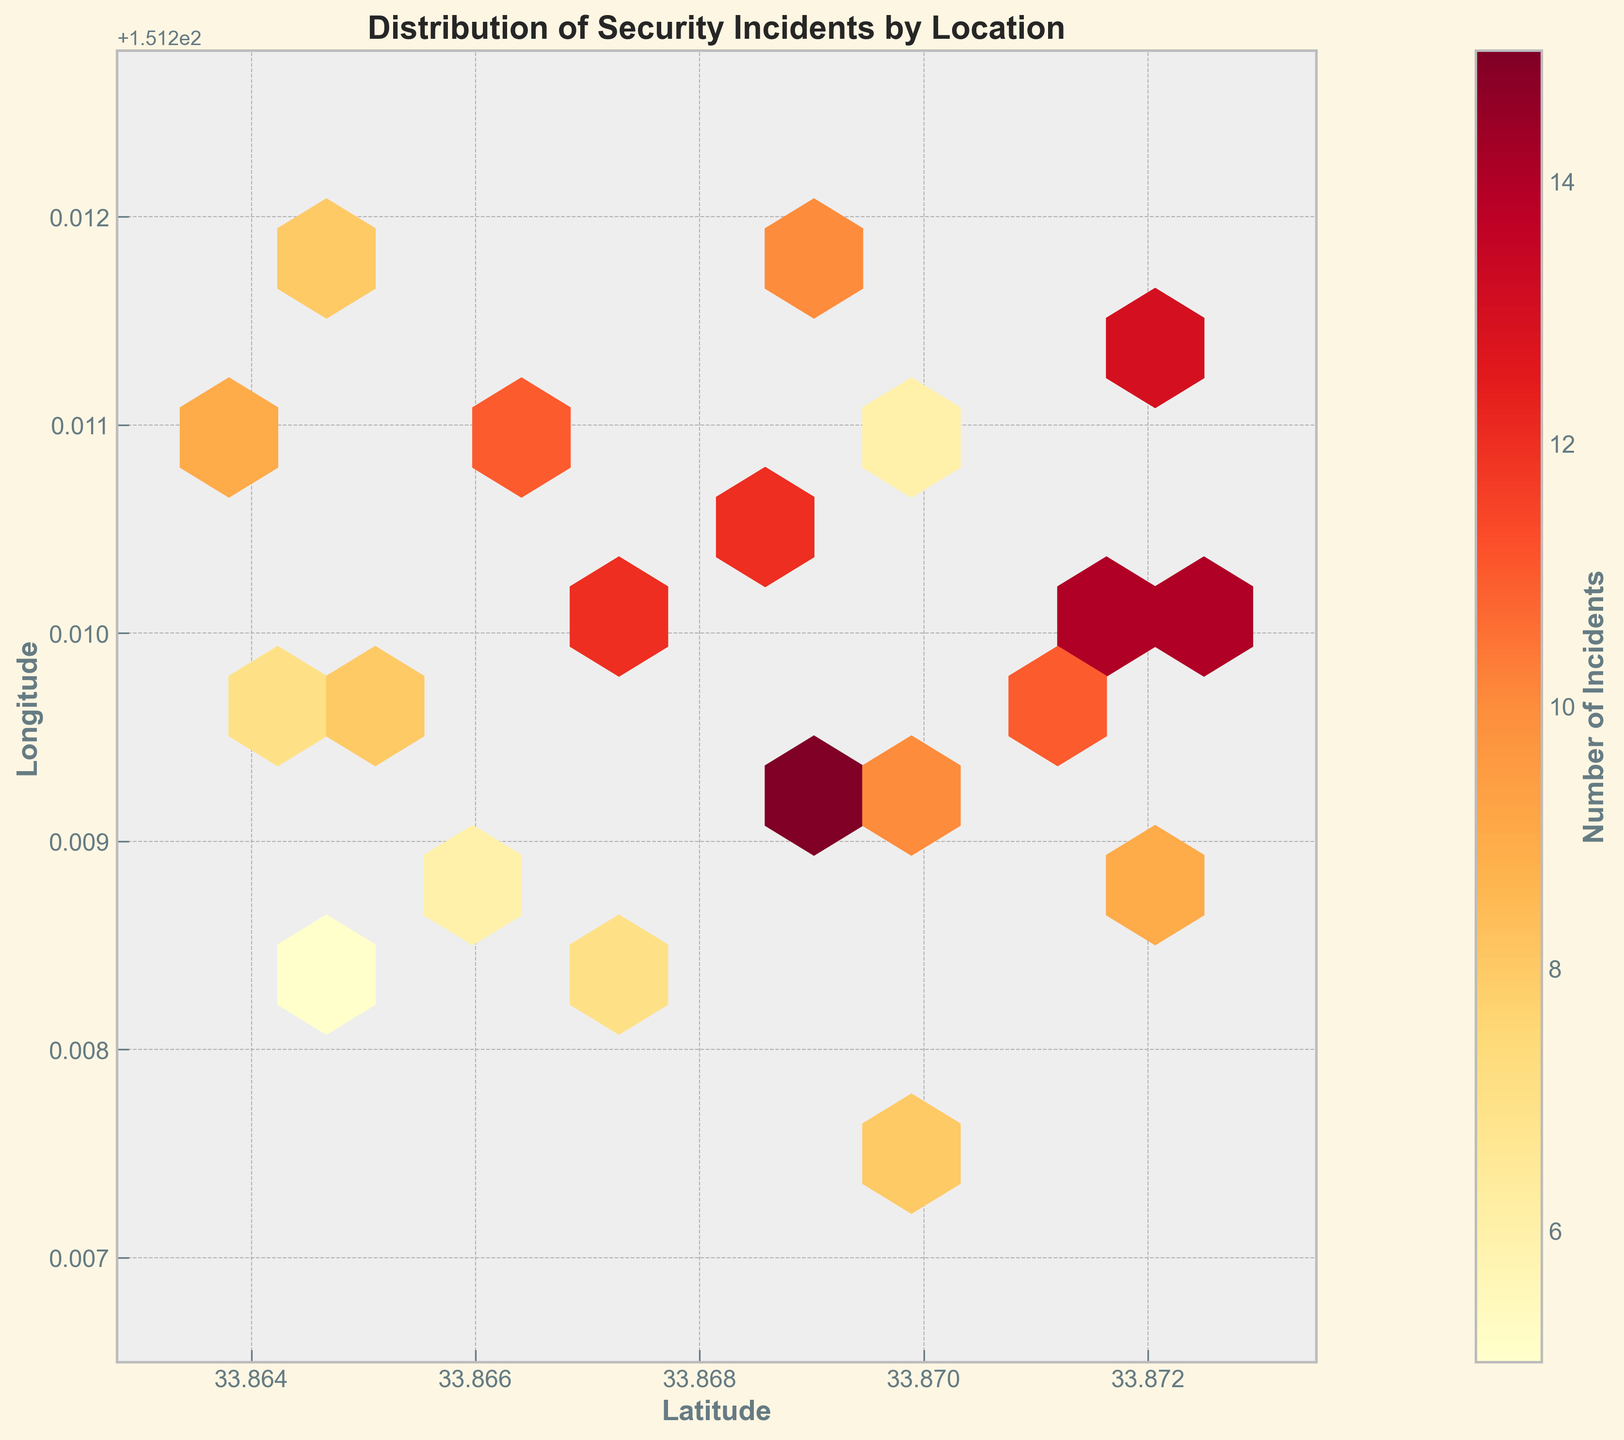What's the title of the plot? The title is displayed at the top of the plot. It provides a brief summary of what the plot is about.
Answer: Distribution of Security Incidents by Location What do the colors in the hexagons represent? The color of each hexagon represents the number of security incidents in that area. This is indicated by the color bar, ranging from lighter to darker colors.
Answer: Number of incidents Which area has the highest number of incidents? Look for the darkest hexagon on the plot, as darker colors indicate a higher number of incidents.
Answer: Around latitude 33.8688 and longitude 151.2093 What is the color of areas with the minimum number of incidents? Refer to the lightest colors visible in the plot and the corresponding range on the color bar.
Answer: Light yellow Which latitude has the most clusters of high incidents? Look at the hexagons along the latitude axis and identify which latitude has the most dark-colored hexagons.
Answer: Around 33.8688 Are there more high-incident areas near 151.2100 longitude or 151.2089 longitude? Compare the number of darker hexagons near the two specified longitudes.
Answer: 151.2100 What is the range of the x-axis (latitude) on the plot? The x-axis range is displayed at the bottom of the plot.
Answer: 33.8628 to 33.8735 Which longitude has fewer security incidents, 151.2111 or 151.2075? Compare the color intensity of hexagons near these two longitudes. Lighter colors indicate fewer incidents.
Answer: 151.2075 In which quadrant of the plot do the largest clusters of incidents appear? Assess which part of the plot (top-left, top-right, bottom-left, bottom-right) contains the majority of dark-colored hexagons.
Answer: Top-right How does the color bar help in interpreting the plot? The color bar maps colors to the number of incidents, aiding in quickly identifying the number of incidents represented by each hexagon's color.
Answer: Maps colors to incidents 